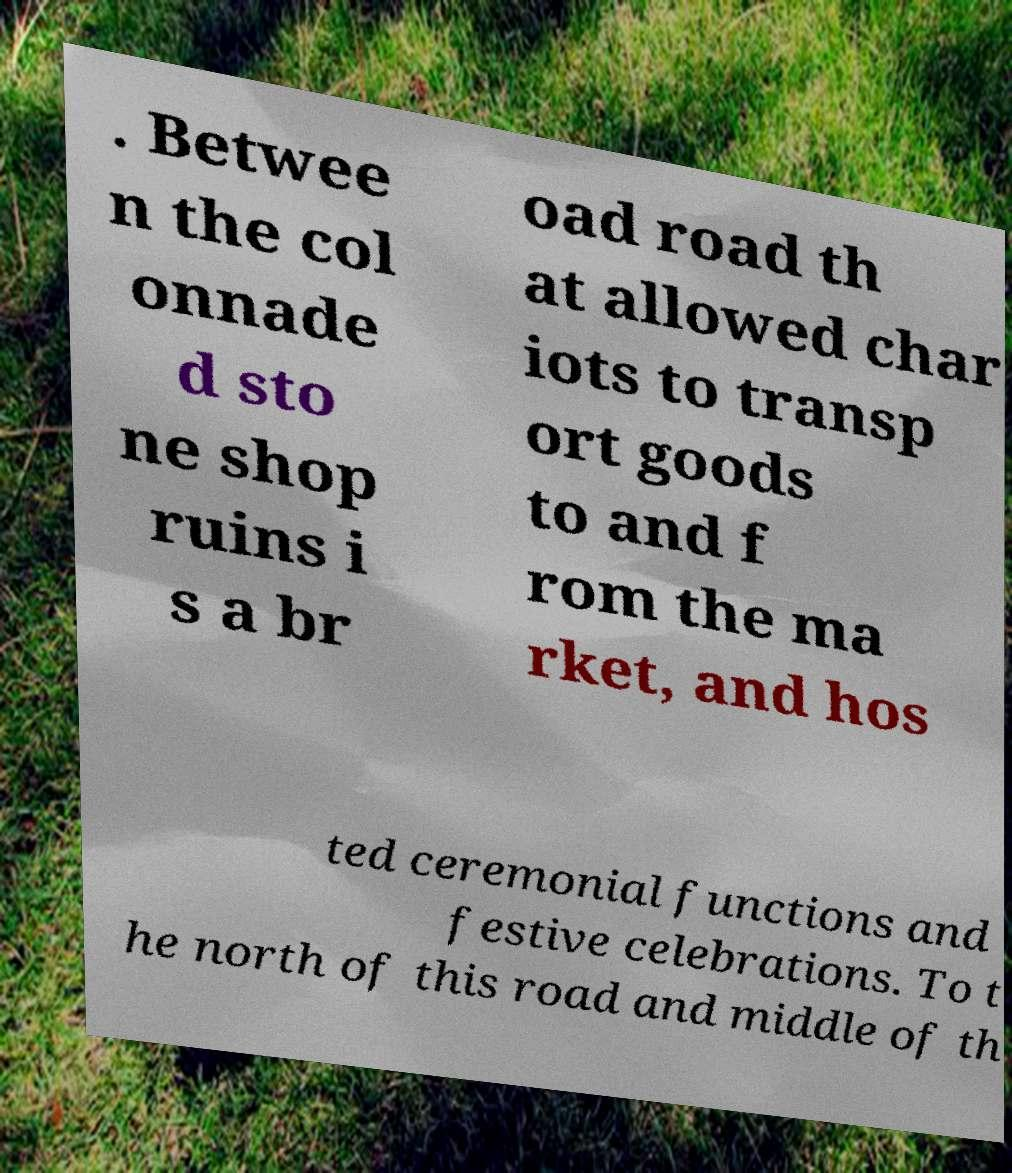Could you assist in decoding the text presented in this image and type it out clearly? . Betwee n the col onnade d sto ne shop ruins i s a br oad road th at allowed char iots to transp ort goods to and f rom the ma rket, and hos ted ceremonial functions and festive celebrations. To t he north of this road and middle of th 